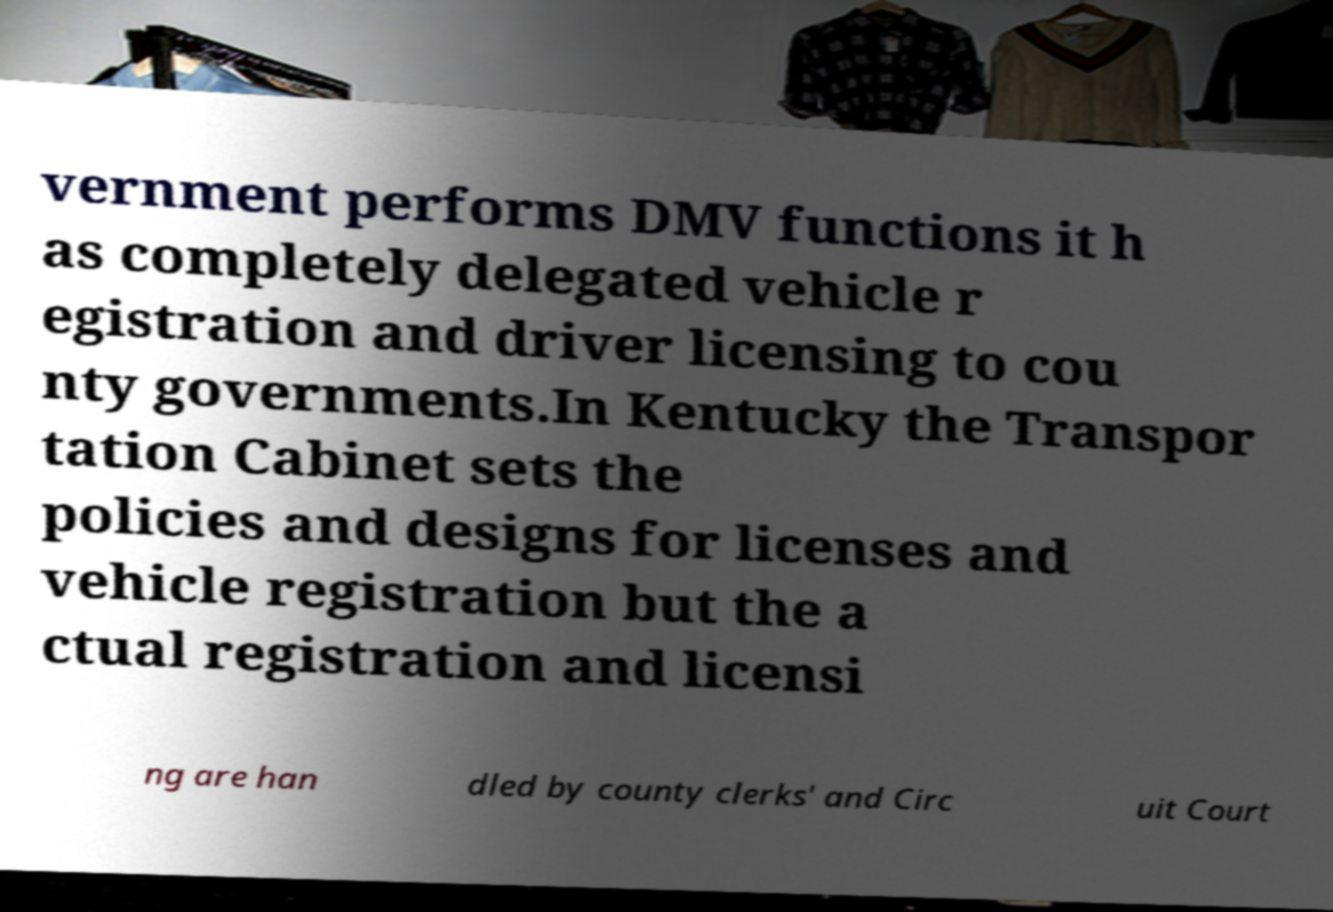There's text embedded in this image that I need extracted. Can you transcribe it verbatim? vernment performs DMV functions it h as completely delegated vehicle r egistration and driver licensing to cou nty governments.In Kentucky the Transpor tation Cabinet sets the policies and designs for licenses and vehicle registration but the a ctual registration and licensi ng are han dled by county clerks' and Circ uit Court 